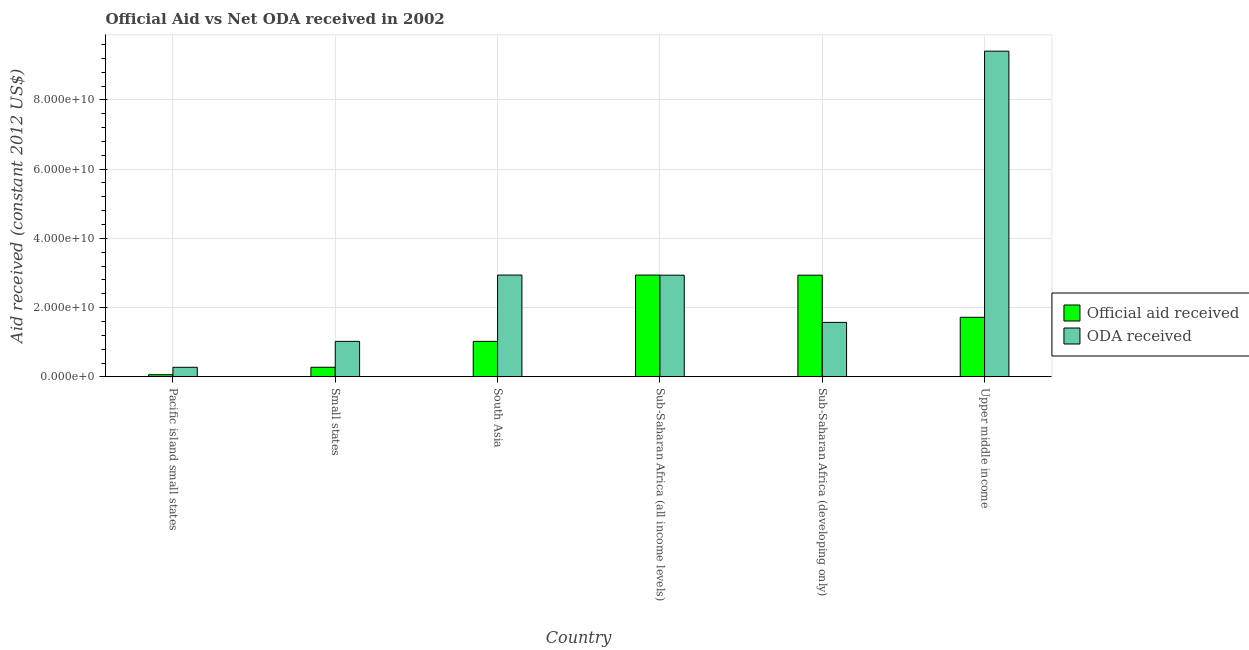How many groups of bars are there?
Provide a succinct answer. 6. Are the number of bars per tick equal to the number of legend labels?
Make the answer very short. Yes. In how many cases, is the number of bars for a given country not equal to the number of legend labels?
Offer a very short reply. 0. What is the official aid received in Sub-Saharan Africa (developing only)?
Make the answer very short. 2.94e+1. Across all countries, what is the maximum oda received?
Keep it short and to the point. 9.41e+1. Across all countries, what is the minimum official aid received?
Give a very brief answer. 6.22e+08. In which country was the official aid received maximum?
Your answer should be compact. Sub-Saharan Africa (all income levels). In which country was the oda received minimum?
Make the answer very short. Pacific island small states. What is the total oda received in the graph?
Provide a succinct answer. 1.82e+11. What is the difference between the official aid received in Pacific island small states and that in South Asia?
Provide a succinct answer. -9.63e+09. What is the difference between the oda received in Sub-Saharan Africa (all income levels) and the official aid received in Pacific island small states?
Make the answer very short. 2.88e+1. What is the average oda received per country?
Give a very brief answer. 3.03e+1. What is the difference between the official aid received and oda received in Upper middle income?
Ensure brevity in your answer.  -7.69e+1. What is the ratio of the official aid received in South Asia to that in Sub-Saharan Africa (developing only)?
Offer a very short reply. 0.35. Is the oda received in Small states less than that in Upper middle income?
Your answer should be very brief. Yes. What is the difference between the highest and the second highest oda received?
Give a very brief answer. 6.47e+1. What is the difference between the highest and the lowest official aid received?
Offer a terse response. 2.88e+1. In how many countries, is the official aid received greater than the average official aid received taken over all countries?
Offer a very short reply. 3. What does the 2nd bar from the left in South Asia represents?
Give a very brief answer. ODA received. What does the 2nd bar from the right in Pacific island small states represents?
Your answer should be compact. Official aid received. Are all the bars in the graph horizontal?
Offer a very short reply. No. How many countries are there in the graph?
Make the answer very short. 6. What is the difference between two consecutive major ticks on the Y-axis?
Your answer should be compact. 2.00e+1. Does the graph contain grids?
Offer a terse response. Yes. Where does the legend appear in the graph?
Your answer should be very brief. Center right. How many legend labels are there?
Provide a short and direct response. 2. What is the title of the graph?
Your response must be concise. Official Aid vs Net ODA received in 2002 . What is the label or title of the X-axis?
Make the answer very short. Country. What is the label or title of the Y-axis?
Your answer should be compact. Aid received (constant 2012 US$). What is the Aid received (constant 2012 US$) of Official aid received in Pacific island small states?
Offer a terse response. 6.22e+08. What is the Aid received (constant 2012 US$) of ODA received in Pacific island small states?
Offer a very short reply. 2.77e+09. What is the Aid received (constant 2012 US$) of Official aid received in Small states?
Make the answer very short. 2.78e+09. What is the Aid received (constant 2012 US$) of ODA received in Small states?
Offer a terse response. 1.03e+1. What is the Aid received (constant 2012 US$) in Official aid received in South Asia?
Your response must be concise. 1.03e+1. What is the Aid received (constant 2012 US$) of ODA received in South Asia?
Provide a short and direct response. 2.94e+1. What is the Aid received (constant 2012 US$) of Official aid received in Sub-Saharan Africa (all income levels)?
Keep it short and to the point. 2.94e+1. What is the Aid received (constant 2012 US$) in ODA received in Sub-Saharan Africa (all income levels)?
Offer a terse response. 2.94e+1. What is the Aid received (constant 2012 US$) of Official aid received in Sub-Saharan Africa (developing only)?
Your answer should be very brief. 2.94e+1. What is the Aid received (constant 2012 US$) in ODA received in Sub-Saharan Africa (developing only)?
Keep it short and to the point. 1.57e+1. What is the Aid received (constant 2012 US$) in Official aid received in Upper middle income?
Ensure brevity in your answer.  1.72e+1. What is the Aid received (constant 2012 US$) in ODA received in Upper middle income?
Your answer should be compact. 9.41e+1. Across all countries, what is the maximum Aid received (constant 2012 US$) of Official aid received?
Keep it short and to the point. 2.94e+1. Across all countries, what is the maximum Aid received (constant 2012 US$) of ODA received?
Keep it short and to the point. 9.41e+1. Across all countries, what is the minimum Aid received (constant 2012 US$) of Official aid received?
Give a very brief answer. 6.22e+08. Across all countries, what is the minimum Aid received (constant 2012 US$) of ODA received?
Provide a succinct answer. 2.77e+09. What is the total Aid received (constant 2012 US$) of Official aid received in the graph?
Offer a terse response. 8.96e+1. What is the total Aid received (constant 2012 US$) in ODA received in the graph?
Your response must be concise. 1.82e+11. What is the difference between the Aid received (constant 2012 US$) of Official aid received in Pacific island small states and that in Small states?
Your answer should be compact. -2.15e+09. What is the difference between the Aid received (constant 2012 US$) in ODA received in Pacific island small states and that in Small states?
Keep it short and to the point. -7.48e+09. What is the difference between the Aid received (constant 2012 US$) of Official aid received in Pacific island small states and that in South Asia?
Give a very brief answer. -9.63e+09. What is the difference between the Aid received (constant 2012 US$) of ODA received in Pacific island small states and that in South Asia?
Provide a short and direct response. -2.66e+1. What is the difference between the Aid received (constant 2012 US$) of Official aid received in Pacific island small states and that in Sub-Saharan Africa (all income levels)?
Keep it short and to the point. -2.88e+1. What is the difference between the Aid received (constant 2012 US$) of ODA received in Pacific island small states and that in Sub-Saharan Africa (all income levels)?
Provide a short and direct response. -2.66e+1. What is the difference between the Aid received (constant 2012 US$) of Official aid received in Pacific island small states and that in Sub-Saharan Africa (developing only)?
Ensure brevity in your answer.  -2.88e+1. What is the difference between the Aid received (constant 2012 US$) in ODA received in Pacific island small states and that in Sub-Saharan Africa (developing only)?
Offer a very short reply. -1.30e+1. What is the difference between the Aid received (constant 2012 US$) in Official aid received in Pacific island small states and that in Upper middle income?
Keep it short and to the point. -1.66e+1. What is the difference between the Aid received (constant 2012 US$) in ODA received in Pacific island small states and that in Upper middle income?
Offer a very short reply. -9.13e+1. What is the difference between the Aid received (constant 2012 US$) in Official aid received in Small states and that in South Asia?
Provide a short and direct response. -7.48e+09. What is the difference between the Aid received (constant 2012 US$) in ODA received in Small states and that in South Asia?
Keep it short and to the point. -1.92e+1. What is the difference between the Aid received (constant 2012 US$) of Official aid received in Small states and that in Sub-Saharan Africa (all income levels)?
Give a very brief answer. -2.66e+1. What is the difference between the Aid received (constant 2012 US$) in ODA received in Small states and that in Sub-Saharan Africa (all income levels)?
Make the answer very short. -1.91e+1. What is the difference between the Aid received (constant 2012 US$) of Official aid received in Small states and that in Sub-Saharan Africa (developing only)?
Provide a short and direct response. -2.66e+1. What is the difference between the Aid received (constant 2012 US$) in ODA received in Small states and that in Sub-Saharan Africa (developing only)?
Your response must be concise. -5.48e+09. What is the difference between the Aid received (constant 2012 US$) in Official aid received in Small states and that in Upper middle income?
Ensure brevity in your answer.  -1.44e+1. What is the difference between the Aid received (constant 2012 US$) of ODA received in Small states and that in Upper middle income?
Provide a short and direct response. -8.38e+1. What is the difference between the Aid received (constant 2012 US$) in Official aid received in South Asia and that in Sub-Saharan Africa (all income levels)?
Provide a short and direct response. -1.92e+1. What is the difference between the Aid received (constant 2012 US$) in ODA received in South Asia and that in Sub-Saharan Africa (all income levels)?
Ensure brevity in your answer.  3.30e+07. What is the difference between the Aid received (constant 2012 US$) in Official aid received in South Asia and that in Sub-Saharan Africa (developing only)?
Offer a terse response. -1.91e+1. What is the difference between the Aid received (constant 2012 US$) in ODA received in South Asia and that in Sub-Saharan Africa (developing only)?
Your answer should be compact. 1.37e+1. What is the difference between the Aid received (constant 2012 US$) of Official aid received in South Asia and that in Upper middle income?
Provide a succinct answer. -6.95e+09. What is the difference between the Aid received (constant 2012 US$) in ODA received in South Asia and that in Upper middle income?
Ensure brevity in your answer.  -6.47e+1. What is the difference between the Aid received (constant 2012 US$) of Official aid received in Sub-Saharan Africa (all income levels) and that in Sub-Saharan Africa (developing only)?
Make the answer very short. 3.30e+07. What is the difference between the Aid received (constant 2012 US$) of ODA received in Sub-Saharan Africa (all income levels) and that in Sub-Saharan Africa (developing only)?
Make the answer very short. 1.36e+1. What is the difference between the Aid received (constant 2012 US$) in Official aid received in Sub-Saharan Africa (all income levels) and that in Upper middle income?
Offer a very short reply. 1.22e+1. What is the difference between the Aid received (constant 2012 US$) in ODA received in Sub-Saharan Africa (all income levels) and that in Upper middle income?
Make the answer very short. -6.47e+1. What is the difference between the Aid received (constant 2012 US$) of Official aid received in Sub-Saharan Africa (developing only) and that in Upper middle income?
Your answer should be very brief. 1.22e+1. What is the difference between the Aid received (constant 2012 US$) in ODA received in Sub-Saharan Africa (developing only) and that in Upper middle income?
Give a very brief answer. -7.83e+1. What is the difference between the Aid received (constant 2012 US$) of Official aid received in Pacific island small states and the Aid received (constant 2012 US$) of ODA received in Small states?
Your response must be concise. -9.63e+09. What is the difference between the Aid received (constant 2012 US$) of Official aid received in Pacific island small states and the Aid received (constant 2012 US$) of ODA received in South Asia?
Offer a very short reply. -2.88e+1. What is the difference between the Aid received (constant 2012 US$) of Official aid received in Pacific island small states and the Aid received (constant 2012 US$) of ODA received in Sub-Saharan Africa (all income levels)?
Offer a terse response. -2.88e+1. What is the difference between the Aid received (constant 2012 US$) of Official aid received in Pacific island small states and the Aid received (constant 2012 US$) of ODA received in Sub-Saharan Africa (developing only)?
Provide a short and direct response. -1.51e+1. What is the difference between the Aid received (constant 2012 US$) in Official aid received in Pacific island small states and the Aid received (constant 2012 US$) in ODA received in Upper middle income?
Keep it short and to the point. -9.35e+1. What is the difference between the Aid received (constant 2012 US$) of Official aid received in Small states and the Aid received (constant 2012 US$) of ODA received in South Asia?
Your response must be concise. -2.66e+1. What is the difference between the Aid received (constant 2012 US$) of Official aid received in Small states and the Aid received (constant 2012 US$) of ODA received in Sub-Saharan Africa (all income levels)?
Offer a terse response. -2.66e+1. What is the difference between the Aid received (constant 2012 US$) in Official aid received in Small states and the Aid received (constant 2012 US$) in ODA received in Sub-Saharan Africa (developing only)?
Make the answer very short. -1.30e+1. What is the difference between the Aid received (constant 2012 US$) in Official aid received in Small states and the Aid received (constant 2012 US$) in ODA received in Upper middle income?
Ensure brevity in your answer.  -9.13e+1. What is the difference between the Aid received (constant 2012 US$) in Official aid received in South Asia and the Aid received (constant 2012 US$) in ODA received in Sub-Saharan Africa (all income levels)?
Your answer should be very brief. -1.91e+1. What is the difference between the Aid received (constant 2012 US$) in Official aid received in South Asia and the Aid received (constant 2012 US$) in ODA received in Sub-Saharan Africa (developing only)?
Your answer should be very brief. -5.48e+09. What is the difference between the Aid received (constant 2012 US$) of Official aid received in South Asia and the Aid received (constant 2012 US$) of ODA received in Upper middle income?
Keep it short and to the point. -8.38e+1. What is the difference between the Aid received (constant 2012 US$) in Official aid received in Sub-Saharan Africa (all income levels) and the Aid received (constant 2012 US$) in ODA received in Sub-Saharan Africa (developing only)?
Your answer should be compact. 1.37e+1. What is the difference between the Aid received (constant 2012 US$) in Official aid received in Sub-Saharan Africa (all income levels) and the Aid received (constant 2012 US$) in ODA received in Upper middle income?
Your answer should be very brief. -6.47e+1. What is the difference between the Aid received (constant 2012 US$) of Official aid received in Sub-Saharan Africa (developing only) and the Aid received (constant 2012 US$) of ODA received in Upper middle income?
Provide a succinct answer. -6.47e+1. What is the average Aid received (constant 2012 US$) of Official aid received per country?
Give a very brief answer. 1.49e+1. What is the average Aid received (constant 2012 US$) in ODA received per country?
Ensure brevity in your answer.  3.03e+1. What is the difference between the Aid received (constant 2012 US$) of Official aid received and Aid received (constant 2012 US$) of ODA received in Pacific island small states?
Make the answer very short. -2.15e+09. What is the difference between the Aid received (constant 2012 US$) in Official aid received and Aid received (constant 2012 US$) in ODA received in Small states?
Offer a very short reply. -7.48e+09. What is the difference between the Aid received (constant 2012 US$) of Official aid received and Aid received (constant 2012 US$) of ODA received in South Asia?
Provide a short and direct response. -1.92e+1. What is the difference between the Aid received (constant 2012 US$) of Official aid received and Aid received (constant 2012 US$) of ODA received in Sub-Saharan Africa (all income levels)?
Offer a terse response. 3.30e+07. What is the difference between the Aid received (constant 2012 US$) in Official aid received and Aid received (constant 2012 US$) in ODA received in Sub-Saharan Africa (developing only)?
Make the answer very short. 1.36e+1. What is the difference between the Aid received (constant 2012 US$) in Official aid received and Aid received (constant 2012 US$) in ODA received in Upper middle income?
Your response must be concise. -7.69e+1. What is the ratio of the Aid received (constant 2012 US$) in Official aid received in Pacific island small states to that in Small states?
Your response must be concise. 0.22. What is the ratio of the Aid received (constant 2012 US$) in ODA received in Pacific island small states to that in Small states?
Ensure brevity in your answer.  0.27. What is the ratio of the Aid received (constant 2012 US$) in Official aid received in Pacific island small states to that in South Asia?
Offer a very short reply. 0.06. What is the ratio of the Aid received (constant 2012 US$) of ODA received in Pacific island small states to that in South Asia?
Offer a very short reply. 0.09. What is the ratio of the Aid received (constant 2012 US$) of Official aid received in Pacific island small states to that in Sub-Saharan Africa (all income levels)?
Provide a short and direct response. 0.02. What is the ratio of the Aid received (constant 2012 US$) in ODA received in Pacific island small states to that in Sub-Saharan Africa (all income levels)?
Offer a terse response. 0.09. What is the ratio of the Aid received (constant 2012 US$) of Official aid received in Pacific island small states to that in Sub-Saharan Africa (developing only)?
Make the answer very short. 0.02. What is the ratio of the Aid received (constant 2012 US$) in ODA received in Pacific island small states to that in Sub-Saharan Africa (developing only)?
Give a very brief answer. 0.18. What is the ratio of the Aid received (constant 2012 US$) of Official aid received in Pacific island small states to that in Upper middle income?
Ensure brevity in your answer.  0.04. What is the ratio of the Aid received (constant 2012 US$) in ODA received in Pacific island small states to that in Upper middle income?
Offer a very short reply. 0.03. What is the ratio of the Aid received (constant 2012 US$) of Official aid received in Small states to that in South Asia?
Offer a terse response. 0.27. What is the ratio of the Aid received (constant 2012 US$) of ODA received in Small states to that in South Asia?
Give a very brief answer. 0.35. What is the ratio of the Aid received (constant 2012 US$) in Official aid received in Small states to that in Sub-Saharan Africa (all income levels)?
Your answer should be compact. 0.09. What is the ratio of the Aid received (constant 2012 US$) of ODA received in Small states to that in Sub-Saharan Africa (all income levels)?
Keep it short and to the point. 0.35. What is the ratio of the Aid received (constant 2012 US$) in Official aid received in Small states to that in Sub-Saharan Africa (developing only)?
Offer a very short reply. 0.09. What is the ratio of the Aid received (constant 2012 US$) of ODA received in Small states to that in Sub-Saharan Africa (developing only)?
Your answer should be compact. 0.65. What is the ratio of the Aid received (constant 2012 US$) of Official aid received in Small states to that in Upper middle income?
Your answer should be very brief. 0.16. What is the ratio of the Aid received (constant 2012 US$) of ODA received in Small states to that in Upper middle income?
Provide a succinct answer. 0.11. What is the ratio of the Aid received (constant 2012 US$) in Official aid received in South Asia to that in Sub-Saharan Africa (all income levels)?
Keep it short and to the point. 0.35. What is the ratio of the Aid received (constant 2012 US$) of ODA received in South Asia to that in Sub-Saharan Africa (all income levels)?
Ensure brevity in your answer.  1. What is the ratio of the Aid received (constant 2012 US$) in Official aid received in South Asia to that in Sub-Saharan Africa (developing only)?
Give a very brief answer. 0.35. What is the ratio of the Aid received (constant 2012 US$) in ODA received in South Asia to that in Sub-Saharan Africa (developing only)?
Give a very brief answer. 1.87. What is the ratio of the Aid received (constant 2012 US$) of Official aid received in South Asia to that in Upper middle income?
Provide a short and direct response. 0.6. What is the ratio of the Aid received (constant 2012 US$) in ODA received in South Asia to that in Upper middle income?
Give a very brief answer. 0.31. What is the ratio of the Aid received (constant 2012 US$) in Official aid received in Sub-Saharan Africa (all income levels) to that in Sub-Saharan Africa (developing only)?
Ensure brevity in your answer.  1. What is the ratio of the Aid received (constant 2012 US$) of ODA received in Sub-Saharan Africa (all income levels) to that in Sub-Saharan Africa (developing only)?
Provide a short and direct response. 1.87. What is the ratio of the Aid received (constant 2012 US$) in Official aid received in Sub-Saharan Africa (all income levels) to that in Upper middle income?
Keep it short and to the point. 1.71. What is the ratio of the Aid received (constant 2012 US$) of ODA received in Sub-Saharan Africa (all income levels) to that in Upper middle income?
Make the answer very short. 0.31. What is the ratio of the Aid received (constant 2012 US$) in Official aid received in Sub-Saharan Africa (developing only) to that in Upper middle income?
Provide a short and direct response. 1.71. What is the ratio of the Aid received (constant 2012 US$) in ODA received in Sub-Saharan Africa (developing only) to that in Upper middle income?
Offer a very short reply. 0.17. What is the difference between the highest and the second highest Aid received (constant 2012 US$) in Official aid received?
Offer a terse response. 3.30e+07. What is the difference between the highest and the second highest Aid received (constant 2012 US$) of ODA received?
Provide a short and direct response. 6.47e+1. What is the difference between the highest and the lowest Aid received (constant 2012 US$) of Official aid received?
Offer a very short reply. 2.88e+1. What is the difference between the highest and the lowest Aid received (constant 2012 US$) in ODA received?
Your response must be concise. 9.13e+1. 